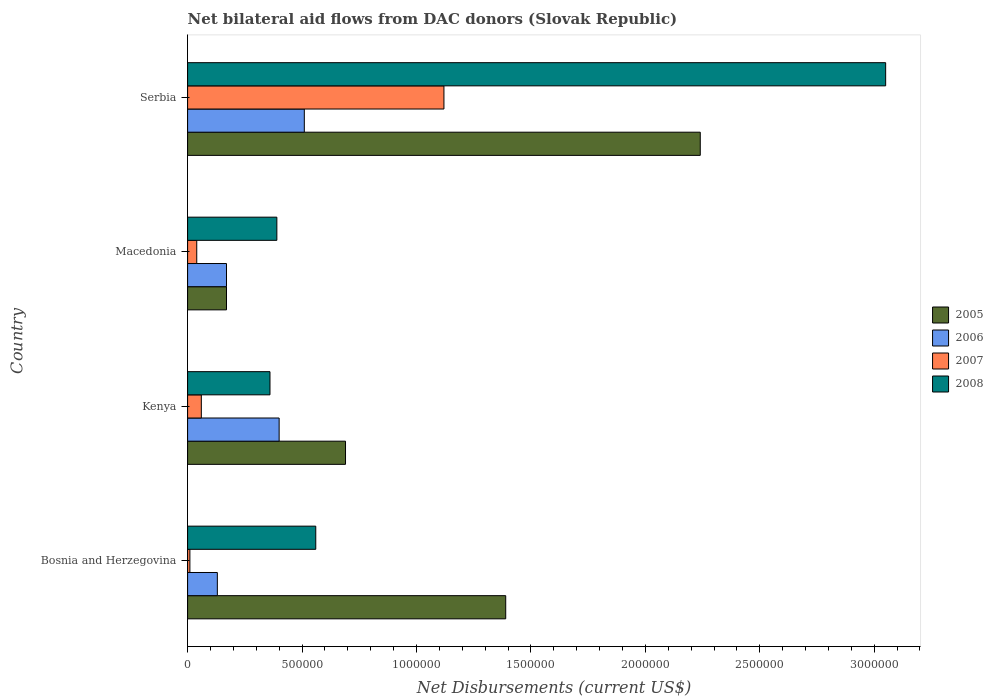How many different coloured bars are there?
Your answer should be compact. 4. Are the number of bars per tick equal to the number of legend labels?
Your answer should be compact. Yes. Are the number of bars on each tick of the Y-axis equal?
Make the answer very short. Yes. What is the label of the 1st group of bars from the top?
Your answer should be compact. Serbia. What is the net bilateral aid flows in 2007 in Bosnia and Herzegovina?
Make the answer very short. 10000. Across all countries, what is the maximum net bilateral aid flows in 2008?
Provide a short and direct response. 3.05e+06. Across all countries, what is the minimum net bilateral aid flows in 2007?
Provide a short and direct response. 10000. In which country was the net bilateral aid flows in 2005 maximum?
Offer a terse response. Serbia. In which country was the net bilateral aid flows in 2008 minimum?
Give a very brief answer. Kenya. What is the total net bilateral aid flows in 2007 in the graph?
Your answer should be compact. 1.23e+06. What is the difference between the net bilateral aid flows in 2008 in Kenya and that in Serbia?
Make the answer very short. -2.69e+06. What is the difference between the net bilateral aid flows in 2007 in Serbia and the net bilateral aid flows in 2008 in Kenya?
Provide a short and direct response. 7.60e+05. What is the average net bilateral aid flows in 2005 per country?
Ensure brevity in your answer.  1.12e+06. What is the difference between the net bilateral aid flows in 2005 and net bilateral aid flows in 2006 in Macedonia?
Your response must be concise. 0. What is the ratio of the net bilateral aid flows in 2005 in Bosnia and Herzegovina to that in Macedonia?
Your answer should be compact. 8.18. Is the net bilateral aid flows in 2007 in Bosnia and Herzegovina less than that in Serbia?
Ensure brevity in your answer.  Yes. What is the difference between the highest and the second highest net bilateral aid flows in 2005?
Your answer should be very brief. 8.50e+05. What is the difference between the highest and the lowest net bilateral aid flows in 2007?
Your answer should be compact. 1.11e+06. In how many countries, is the net bilateral aid flows in 2005 greater than the average net bilateral aid flows in 2005 taken over all countries?
Your answer should be compact. 2. Is the sum of the net bilateral aid flows in 2006 in Kenya and Macedonia greater than the maximum net bilateral aid flows in 2005 across all countries?
Provide a succinct answer. No. Is it the case that in every country, the sum of the net bilateral aid flows in 2008 and net bilateral aid flows in 2006 is greater than the sum of net bilateral aid flows in 2005 and net bilateral aid flows in 2007?
Give a very brief answer. No. How many bars are there?
Provide a short and direct response. 16. Are all the bars in the graph horizontal?
Your answer should be very brief. Yes. How many countries are there in the graph?
Give a very brief answer. 4. Does the graph contain any zero values?
Make the answer very short. No. Does the graph contain grids?
Provide a short and direct response. No. How many legend labels are there?
Keep it short and to the point. 4. What is the title of the graph?
Make the answer very short. Net bilateral aid flows from DAC donors (Slovak Republic). Does "1989" appear as one of the legend labels in the graph?
Provide a succinct answer. No. What is the label or title of the X-axis?
Give a very brief answer. Net Disbursements (current US$). What is the Net Disbursements (current US$) of 2005 in Bosnia and Herzegovina?
Offer a terse response. 1.39e+06. What is the Net Disbursements (current US$) in 2006 in Bosnia and Herzegovina?
Ensure brevity in your answer.  1.30e+05. What is the Net Disbursements (current US$) of 2008 in Bosnia and Herzegovina?
Give a very brief answer. 5.60e+05. What is the Net Disbursements (current US$) of 2005 in Kenya?
Provide a short and direct response. 6.90e+05. What is the Net Disbursements (current US$) of 2006 in Kenya?
Ensure brevity in your answer.  4.00e+05. What is the Net Disbursements (current US$) in 2005 in Serbia?
Keep it short and to the point. 2.24e+06. What is the Net Disbursements (current US$) in 2006 in Serbia?
Offer a terse response. 5.10e+05. What is the Net Disbursements (current US$) of 2007 in Serbia?
Provide a short and direct response. 1.12e+06. What is the Net Disbursements (current US$) of 2008 in Serbia?
Your response must be concise. 3.05e+06. Across all countries, what is the maximum Net Disbursements (current US$) of 2005?
Your answer should be compact. 2.24e+06. Across all countries, what is the maximum Net Disbursements (current US$) of 2006?
Give a very brief answer. 5.10e+05. Across all countries, what is the maximum Net Disbursements (current US$) of 2007?
Provide a short and direct response. 1.12e+06. Across all countries, what is the maximum Net Disbursements (current US$) of 2008?
Provide a short and direct response. 3.05e+06. What is the total Net Disbursements (current US$) of 2005 in the graph?
Ensure brevity in your answer.  4.49e+06. What is the total Net Disbursements (current US$) in 2006 in the graph?
Provide a short and direct response. 1.21e+06. What is the total Net Disbursements (current US$) of 2007 in the graph?
Provide a short and direct response. 1.23e+06. What is the total Net Disbursements (current US$) in 2008 in the graph?
Give a very brief answer. 4.36e+06. What is the difference between the Net Disbursements (current US$) of 2008 in Bosnia and Herzegovina and that in Kenya?
Give a very brief answer. 2.00e+05. What is the difference between the Net Disbursements (current US$) in 2005 in Bosnia and Herzegovina and that in Macedonia?
Ensure brevity in your answer.  1.22e+06. What is the difference between the Net Disbursements (current US$) in 2006 in Bosnia and Herzegovina and that in Macedonia?
Offer a very short reply. -4.00e+04. What is the difference between the Net Disbursements (current US$) of 2007 in Bosnia and Herzegovina and that in Macedonia?
Your answer should be very brief. -3.00e+04. What is the difference between the Net Disbursements (current US$) in 2008 in Bosnia and Herzegovina and that in Macedonia?
Give a very brief answer. 1.70e+05. What is the difference between the Net Disbursements (current US$) of 2005 in Bosnia and Herzegovina and that in Serbia?
Provide a succinct answer. -8.50e+05. What is the difference between the Net Disbursements (current US$) of 2006 in Bosnia and Herzegovina and that in Serbia?
Keep it short and to the point. -3.80e+05. What is the difference between the Net Disbursements (current US$) in 2007 in Bosnia and Herzegovina and that in Serbia?
Offer a terse response. -1.11e+06. What is the difference between the Net Disbursements (current US$) of 2008 in Bosnia and Herzegovina and that in Serbia?
Offer a very short reply. -2.49e+06. What is the difference between the Net Disbursements (current US$) of 2005 in Kenya and that in Macedonia?
Make the answer very short. 5.20e+05. What is the difference between the Net Disbursements (current US$) in 2006 in Kenya and that in Macedonia?
Give a very brief answer. 2.30e+05. What is the difference between the Net Disbursements (current US$) of 2007 in Kenya and that in Macedonia?
Your answer should be compact. 2.00e+04. What is the difference between the Net Disbursements (current US$) of 2008 in Kenya and that in Macedonia?
Make the answer very short. -3.00e+04. What is the difference between the Net Disbursements (current US$) of 2005 in Kenya and that in Serbia?
Your response must be concise. -1.55e+06. What is the difference between the Net Disbursements (current US$) in 2006 in Kenya and that in Serbia?
Offer a terse response. -1.10e+05. What is the difference between the Net Disbursements (current US$) of 2007 in Kenya and that in Serbia?
Provide a succinct answer. -1.06e+06. What is the difference between the Net Disbursements (current US$) of 2008 in Kenya and that in Serbia?
Your response must be concise. -2.69e+06. What is the difference between the Net Disbursements (current US$) of 2005 in Macedonia and that in Serbia?
Provide a short and direct response. -2.07e+06. What is the difference between the Net Disbursements (current US$) in 2007 in Macedonia and that in Serbia?
Provide a short and direct response. -1.08e+06. What is the difference between the Net Disbursements (current US$) in 2008 in Macedonia and that in Serbia?
Give a very brief answer. -2.66e+06. What is the difference between the Net Disbursements (current US$) in 2005 in Bosnia and Herzegovina and the Net Disbursements (current US$) in 2006 in Kenya?
Give a very brief answer. 9.90e+05. What is the difference between the Net Disbursements (current US$) of 2005 in Bosnia and Herzegovina and the Net Disbursements (current US$) of 2007 in Kenya?
Provide a short and direct response. 1.33e+06. What is the difference between the Net Disbursements (current US$) in 2005 in Bosnia and Herzegovina and the Net Disbursements (current US$) in 2008 in Kenya?
Provide a succinct answer. 1.03e+06. What is the difference between the Net Disbursements (current US$) in 2006 in Bosnia and Herzegovina and the Net Disbursements (current US$) in 2007 in Kenya?
Your answer should be compact. 7.00e+04. What is the difference between the Net Disbursements (current US$) of 2006 in Bosnia and Herzegovina and the Net Disbursements (current US$) of 2008 in Kenya?
Offer a very short reply. -2.30e+05. What is the difference between the Net Disbursements (current US$) of 2007 in Bosnia and Herzegovina and the Net Disbursements (current US$) of 2008 in Kenya?
Provide a short and direct response. -3.50e+05. What is the difference between the Net Disbursements (current US$) of 2005 in Bosnia and Herzegovina and the Net Disbursements (current US$) of 2006 in Macedonia?
Your answer should be compact. 1.22e+06. What is the difference between the Net Disbursements (current US$) of 2005 in Bosnia and Herzegovina and the Net Disbursements (current US$) of 2007 in Macedonia?
Keep it short and to the point. 1.35e+06. What is the difference between the Net Disbursements (current US$) of 2007 in Bosnia and Herzegovina and the Net Disbursements (current US$) of 2008 in Macedonia?
Make the answer very short. -3.80e+05. What is the difference between the Net Disbursements (current US$) of 2005 in Bosnia and Herzegovina and the Net Disbursements (current US$) of 2006 in Serbia?
Give a very brief answer. 8.80e+05. What is the difference between the Net Disbursements (current US$) in 2005 in Bosnia and Herzegovina and the Net Disbursements (current US$) in 2008 in Serbia?
Keep it short and to the point. -1.66e+06. What is the difference between the Net Disbursements (current US$) of 2006 in Bosnia and Herzegovina and the Net Disbursements (current US$) of 2007 in Serbia?
Make the answer very short. -9.90e+05. What is the difference between the Net Disbursements (current US$) in 2006 in Bosnia and Herzegovina and the Net Disbursements (current US$) in 2008 in Serbia?
Your answer should be compact. -2.92e+06. What is the difference between the Net Disbursements (current US$) in 2007 in Bosnia and Herzegovina and the Net Disbursements (current US$) in 2008 in Serbia?
Provide a short and direct response. -3.04e+06. What is the difference between the Net Disbursements (current US$) of 2005 in Kenya and the Net Disbursements (current US$) of 2006 in Macedonia?
Keep it short and to the point. 5.20e+05. What is the difference between the Net Disbursements (current US$) in 2005 in Kenya and the Net Disbursements (current US$) in 2007 in Macedonia?
Your response must be concise. 6.50e+05. What is the difference between the Net Disbursements (current US$) of 2005 in Kenya and the Net Disbursements (current US$) of 2008 in Macedonia?
Ensure brevity in your answer.  3.00e+05. What is the difference between the Net Disbursements (current US$) of 2006 in Kenya and the Net Disbursements (current US$) of 2008 in Macedonia?
Give a very brief answer. 10000. What is the difference between the Net Disbursements (current US$) of 2007 in Kenya and the Net Disbursements (current US$) of 2008 in Macedonia?
Provide a short and direct response. -3.30e+05. What is the difference between the Net Disbursements (current US$) in 2005 in Kenya and the Net Disbursements (current US$) in 2006 in Serbia?
Ensure brevity in your answer.  1.80e+05. What is the difference between the Net Disbursements (current US$) of 2005 in Kenya and the Net Disbursements (current US$) of 2007 in Serbia?
Make the answer very short. -4.30e+05. What is the difference between the Net Disbursements (current US$) of 2005 in Kenya and the Net Disbursements (current US$) of 2008 in Serbia?
Make the answer very short. -2.36e+06. What is the difference between the Net Disbursements (current US$) in 2006 in Kenya and the Net Disbursements (current US$) in 2007 in Serbia?
Offer a terse response. -7.20e+05. What is the difference between the Net Disbursements (current US$) of 2006 in Kenya and the Net Disbursements (current US$) of 2008 in Serbia?
Give a very brief answer. -2.65e+06. What is the difference between the Net Disbursements (current US$) of 2007 in Kenya and the Net Disbursements (current US$) of 2008 in Serbia?
Make the answer very short. -2.99e+06. What is the difference between the Net Disbursements (current US$) in 2005 in Macedonia and the Net Disbursements (current US$) in 2007 in Serbia?
Keep it short and to the point. -9.50e+05. What is the difference between the Net Disbursements (current US$) of 2005 in Macedonia and the Net Disbursements (current US$) of 2008 in Serbia?
Your answer should be compact. -2.88e+06. What is the difference between the Net Disbursements (current US$) in 2006 in Macedonia and the Net Disbursements (current US$) in 2007 in Serbia?
Make the answer very short. -9.50e+05. What is the difference between the Net Disbursements (current US$) of 2006 in Macedonia and the Net Disbursements (current US$) of 2008 in Serbia?
Your response must be concise. -2.88e+06. What is the difference between the Net Disbursements (current US$) of 2007 in Macedonia and the Net Disbursements (current US$) of 2008 in Serbia?
Your answer should be compact. -3.01e+06. What is the average Net Disbursements (current US$) of 2005 per country?
Provide a short and direct response. 1.12e+06. What is the average Net Disbursements (current US$) in 2006 per country?
Offer a terse response. 3.02e+05. What is the average Net Disbursements (current US$) in 2007 per country?
Ensure brevity in your answer.  3.08e+05. What is the average Net Disbursements (current US$) of 2008 per country?
Provide a short and direct response. 1.09e+06. What is the difference between the Net Disbursements (current US$) of 2005 and Net Disbursements (current US$) of 2006 in Bosnia and Herzegovina?
Ensure brevity in your answer.  1.26e+06. What is the difference between the Net Disbursements (current US$) in 2005 and Net Disbursements (current US$) in 2007 in Bosnia and Herzegovina?
Ensure brevity in your answer.  1.38e+06. What is the difference between the Net Disbursements (current US$) of 2005 and Net Disbursements (current US$) of 2008 in Bosnia and Herzegovina?
Give a very brief answer. 8.30e+05. What is the difference between the Net Disbursements (current US$) of 2006 and Net Disbursements (current US$) of 2008 in Bosnia and Herzegovina?
Your answer should be compact. -4.30e+05. What is the difference between the Net Disbursements (current US$) in 2007 and Net Disbursements (current US$) in 2008 in Bosnia and Herzegovina?
Offer a very short reply. -5.50e+05. What is the difference between the Net Disbursements (current US$) in 2005 and Net Disbursements (current US$) in 2006 in Kenya?
Your response must be concise. 2.90e+05. What is the difference between the Net Disbursements (current US$) in 2005 and Net Disbursements (current US$) in 2007 in Kenya?
Your response must be concise. 6.30e+05. What is the difference between the Net Disbursements (current US$) in 2005 and Net Disbursements (current US$) in 2008 in Kenya?
Ensure brevity in your answer.  3.30e+05. What is the difference between the Net Disbursements (current US$) of 2006 and Net Disbursements (current US$) of 2007 in Kenya?
Your answer should be very brief. 3.40e+05. What is the difference between the Net Disbursements (current US$) in 2006 and Net Disbursements (current US$) in 2008 in Kenya?
Your answer should be very brief. 4.00e+04. What is the difference between the Net Disbursements (current US$) of 2005 and Net Disbursements (current US$) of 2007 in Macedonia?
Provide a short and direct response. 1.30e+05. What is the difference between the Net Disbursements (current US$) of 2005 and Net Disbursements (current US$) of 2008 in Macedonia?
Your response must be concise. -2.20e+05. What is the difference between the Net Disbursements (current US$) of 2006 and Net Disbursements (current US$) of 2007 in Macedonia?
Your answer should be very brief. 1.30e+05. What is the difference between the Net Disbursements (current US$) in 2006 and Net Disbursements (current US$) in 2008 in Macedonia?
Make the answer very short. -2.20e+05. What is the difference between the Net Disbursements (current US$) of 2007 and Net Disbursements (current US$) of 2008 in Macedonia?
Your answer should be compact. -3.50e+05. What is the difference between the Net Disbursements (current US$) of 2005 and Net Disbursements (current US$) of 2006 in Serbia?
Keep it short and to the point. 1.73e+06. What is the difference between the Net Disbursements (current US$) of 2005 and Net Disbursements (current US$) of 2007 in Serbia?
Ensure brevity in your answer.  1.12e+06. What is the difference between the Net Disbursements (current US$) of 2005 and Net Disbursements (current US$) of 2008 in Serbia?
Your answer should be compact. -8.10e+05. What is the difference between the Net Disbursements (current US$) in 2006 and Net Disbursements (current US$) in 2007 in Serbia?
Offer a very short reply. -6.10e+05. What is the difference between the Net Disbursements (current US$) of 2006 and Net Disbursements (current US$) of 2008 in Serbia?
Offer a terse response. -2.54e+06. What is the difference between the Net Disbursements (current US$) in 2007 and Net Disbursements (current US$) in 2008 in Serbia?
Keep it short and to the point. -1.93e+06. What is the ratio of the Net Disbursements (current US$) in 2005 in Bosnia and Herzegovina to that in Kenya?
Offer a very short reply. 2.01. What is the ratio of the Net Disbursements (current US$) of 2006 in Bosnia and Herzegovina to that in Kenya?
Offer a terse response. 0.33. What is the ratio of the Net Disbursements (current US$) in 2008 in Bosnia and Herzegovina to that in Kenya?
Keep it short and to the point. 1.56. What is the ratio of the Net Disbursements (current US$) of 2005 in Bosnia and Herzegovina to that in Macedonia?
Offer a terse response. 8.18. What is the ratio of the Net Disbursements (current US$) of 2006 in Bosnia and Herzegovina to that in Macedonia?
Keep it short and to the point. 0.76. What is the ratio of the Net Disbursements (current US$) of 2007 in Bosnia and Herzegovina to that in Macedonia?
Your response must be concise. 0.25. What is the ratio of the Net Disbursements (current US$) of 2008 in Bosnia and Herzegovina to that in Macedonia?
Your answer should be compact. 1.44. What is the ratio of the Net Disbursements (current US$) of 2005 in Bosnia and Herzegovina to that in Serbia?
Your answer should be compact. 0.62. What is the ratio of the Net Disbursements (current US$) of 2006 in Bosnia and Herzegovina to that in Serbia?
Provide a short and direct response. 0.25. What is the ratio of the Net Disbursements (current US$) in 2007 in Bosnia and Herzegovina to that in Serbia?
Offer a very short reply. 0.01. What is the ratio of the Net Disbursements (current US$) of 2008 in Bosnia and Herzegovina to that in Serbia?
Your answer should be compact. 0.18. What is the ratio of the Net Disbursements (current US$) of 2005 in Kenya to that in Macedonia?
Offer a terse response. 4.06. What is the ratio of the Net Disbursements (current US$) of 2006 in Kenya to that in Macedonia?
Provide a succinct answer. 2.35. What is the ratio of the Net Disbursements (current US$) in 2007 in Kenya to that in Macedonia?
Keep it short and to the point. 1.5. What is the ratio of the Net Disbursements (current US$) of 2008 in Kenya to that in Macedonia?
Your answer should be compact. 0.92. What is the ratio of the Net Disbursements (current US$) in 2005 in Kenya to that in Serbia?
Offer a terse response. 0.31. What is the ratio of the Net Disbursements (current US$) in 2006 in Kenya to that in Serbia?
Provide a succinct answer. 0.78. What is the ratio of the Net Disbursements (current US$) of 2007 in Kenya to that in Serbia?
Ensure brevity in your answer.  0.05. What is the ratio of the Net Disbursements (current US$) in 2008 in Kenya to that in Serbia?
Give a very brief answer. 0.12. What is the ratio of the Net Disbursements (current US$) in 2005 in Macedonia to that in Serbia?
Your answer should be compact. 0.08. What is the ratio of the Net Disbursements (current US$) in 2006 in Macedonia to that in Serbia?
Keep it short and to the point. 0.33. What is the ratio of the Net Disbursements (current US$) in 2007 in Macedonia to that in Serbia?
Make the answer very short. 0.04. What is the ratio of the Net Disbursements (current US$) of 2008 in Macedonia to that in Serbia?
Ensure brevity in your answer.  0.13. What is the difference between the highest and the second highest Net Disbursements (current US$) in 2005?
Your answer should be very brief. 8.50e+05. What is the difference between the highest and the second highest Net Disbursements (current US$) in 2006?
Give a very brief answer. 1.10e+05. What is the difference between the highest and the second highest Net Disbursements (current US$) in 2007?
Provide a short and direct response. 1.06e+06. What is the difference between the highest and the second highest Net Disbursements (current US$) of 2008?
Offer a very short reply. 2.49e+06. What is the difference between the highest and the lowest Net Disbursements (current US$) of 2005?
Your response must be concise. 2.07e+06. What is the difference between the highest and the lowest Net Disbursements (current US$) in 2006?
Offer a terse response. 3.80e+05. What is the difference between the highest and the lowest Net Disbursements (current US$) in 2007?
Your answer should be very brief. 1.11e+06. What is the difference between the highest and the lowest Net Disbursements (current US$) in 2008?
Your answer should be very brief. 2.69e+06. 